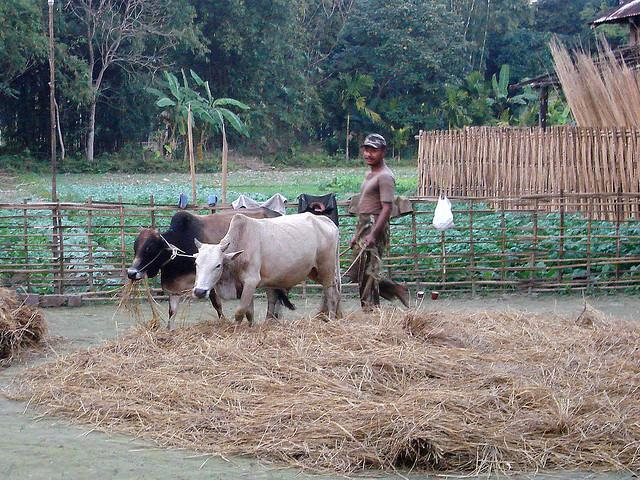What diet are the cows here on? hay 